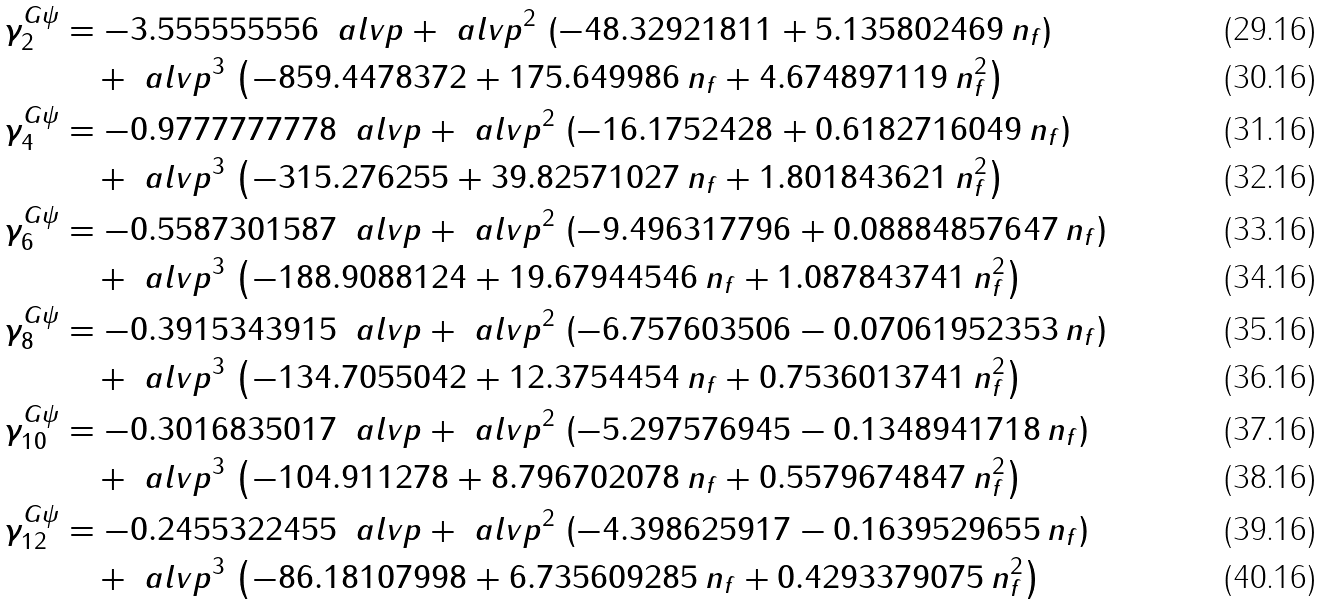Convert formula to latex. <formula><loc_0><loc_0><loc_500><loc_500>\gamma ^ { G \psi } _ { 2 } & = - 3 . 5 5 5 5 5 5 5 5 6 \, \ a l v p + { \ a l v p ^ { 2 } } \, \left ( - 4 8 . 3 2 9 2 1 8 1 1 + 5 . 1 3 5 8 0 2 4 6 9 \, n _ { f } \right ) & \\ & \quad + \ a l v p ^ { 3 } \, \left ( - 8 5 9 . 4 4 7 8 3 7 2 + 1 7 5 . 6 4 9 9 8 6 \, n _ { f } + 4 . 6 7 4 8 9 7 1 1 9 \, { n _ { f } ^ { 2 } } \right ) & \\ \gamma ^ { G \psi } _ { 4 } & = - 0 . 9 7 7 7 7 7 7 7 7 8 \, \ a l v p + { \ a l v p ^ { 2 } } \, \left ( - 1 6 . 1 7 5 2 4 2 8 + 0 . 6 1 8 2 7 1 6 0 4 9 \, n _ { f } \right ) & \\ & \quad + \ a l v p ^ { 3 } \, \left ( - 3 1 5 . 2 7 6 2 5 5 + 3 9 . 8 2 5 7 1 0 2 7 \, n _ { f } + 1 . 8 0 1 8 4 3 6 2 1 \, { n _ { f } ^ { 2 } } \right ) & \\ \gamma ^ { G \psi } _ { 6 } & = - 0 . 5 5 8 7 3 0 1 5 8 7 \, \ a l v p + { \ a l v p ^ { 2 } } \, \left ( - 9 . 4 9 6 3 1 7 7 9 6 + 0 . 0 8 8 8 4 8 5 7 6 4 7 \, n _ { f } \right ) & \\ & \quad + \ a l v p ^ { 3 } \, \left ( - 1 8 8 . 9 0 8 8 1 2 4 + 1 9 . 6 7 9 4 4 5 4 6 \, n _ { f } + 1 . 0 8 7 8 4 3 7 4 1 \, { n _ { f } ^ { 2 } } \right ) & \\ \gamma ^ { G \psi } _ { 8 } & = - 0 . 3 9 1 5 3 4 3 9 1 5 \, \ a l v p + { \ a l v p ^ { 2 } } \, \left ( - 6 . 7 5 7 6 0 3 5 0 6 - 0 . 0 7 0 6 1 9 5 2 3 5 3 \, n _ { f } \right ) & \\ & \quad + \ a l v p ^ { 3 } \, \left ( - 1 3 4 . 7 0 5 5 0 4 2 + 1 2 . 3 7 5 4 4 5 4 \, n _ { f } + 0 . 7 5 3 6 0 1 3 7 4 1 \, { n _ { f } ^ { 2 } } \right ) & \\ \gamma ^ { G \psi } _ { 1 0 } & = - 0 . 3 0 1 6 8 3 5 0 1 7 \, \ a l v p + { \ a l v p ^ { 2 } } \, \left ( - 5 . 2 9 7 5 7 6 9 4 5 - 0 . 1 3 4 8 9 4 1 7 1 8 \, n _ { f } \right ) & \\ & \quad + \ a l v p ^ { 3 } \, \left ( - 1 0 4 . 9 1 1 2 7 8 + 8 . 7 9 6 7 0 2 0 7 8 \, n _ { f } + 0 . 5 5 7 9 6 7 4 8 4 7 \, { n _ { f } ^ { 2 } } \right ) & \\ \gamma ^ { G \psi } _ { 1 2 } & = - 0 . 2 4 5 5 3 2 2 4 5 5 \, \ a l v p + { \ a l v p ^ { 2 } } \, \left ( - 4 . 3 9 8 6 2 5 9 1 7 - 0 . 1 6 3 9 5 2 9 6 5 5 \, n _ { f } \right ) & \\ & \quad + \ a l v p ^ { 3 } \, \left ( - 8 6 . 1 8 1 0 7 9 9 8 + 6 . 7 3 5 6 0 9 2 8 5 \, n _ { f } + 0 . 4 2 9 3 3 7 9 0 7 5 \, { n _ { f } ^ { 2 } } \right ) &</formula> 